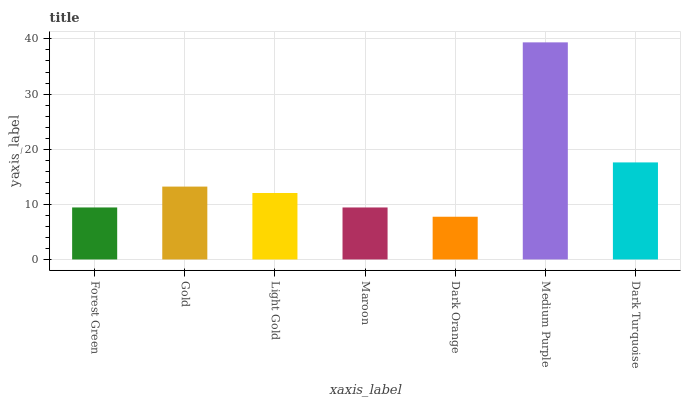Is Dark Orange the minimum?
Answer yes or no. Yes. Is Medium Purple the maximum?
Answer yes or no. Yes. Is Gold the minimum?
Answer yes or no. No. Is Gold the maximum?
Answer yes or no. No. Is Gold greater than Forest Green?
Answer yes or no. Yes. Is Forest Green less than Gold?
Answer yes or no. Yes. Is Forest Green greater than Gold?
Answer yes or no. No. Is Gold less than Forest Green?
Answer yes or no. No. Is Light Gold the high median?
Answer yes or no. Yes. Is Light Gold the low median?
Answer yes or no. Yes. Is Gold the high median?
Answer yes or no. No. Is Gold the low median?
Answer yes or no. No. 